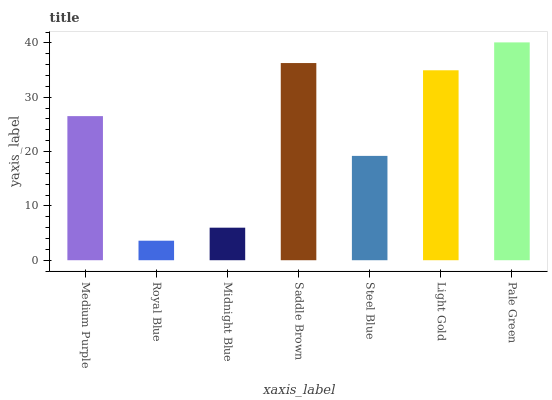Is Royal Blue the minimum?
Answer yes or no. Yes. Is Pale Green the maximum?
Answer yes or no. Yes. Is Midnight Blue the minimum?
Answer yes or no. No. Is Midnight Blue the maximum?
Answer yes or no. No. Is Midnight Blue greater than Royal Blue?
Answer yes or no. Yes. Is Royal Blue less than Midnight Blue?
Answer yes or no. Yes. Is Royal Blue greater than Midnight Blue?
Answer yes or no. No. Is Midnight Blue less than Royal Blue?
Answer yes or no. No. Is Medium Purple the high median?
Answer yes or no. Yes. Is Medium Purple the low median?
Answer yes or no. Yes. Is Midnight Blue the high median?
Answer yes or no. No. Is Midnight Blue the low median?
Answer yes or no. No. 